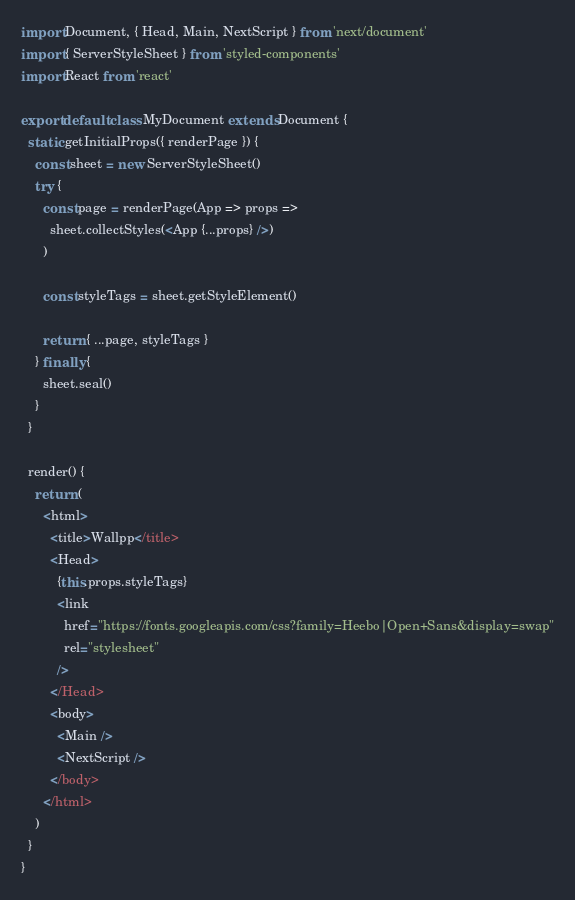Convert code to text. <code><loc_0><loc_0><loc_500><loc_500><_JavaScript_>import Document, { Head, Main, NextScript } from 'next/document'
import { ServerStyleSheet } from 'styled-components'
import React from 'react'

export default class MyDocument extends Document {
  static getInitialProps({ renderPage }) {
    const sheet = new ServerStyleSheet()
    try {
      const page = renderPage(App => props =>
        sheet.collectStyles(<App {...props} />)
      )

      const styleTags = sheet.getStyleElement()

      return { ...page, styleTags }
    } finally {
      sheet.seal()
    }
  }

  render() {
    return (
      <html>
        <title>Wallpp</title>
        <Head>
          {this.props.styleTags}
          <link
            href="https://fonts.googleapis.com/css?family=Heebo|Open+Sans&display=swap"
            rel="stylesheet"
          />
        </Head>
        <body>
          <Main />
          <NextScript />
        </body>
      </html>
    )
  }
}
</code> 